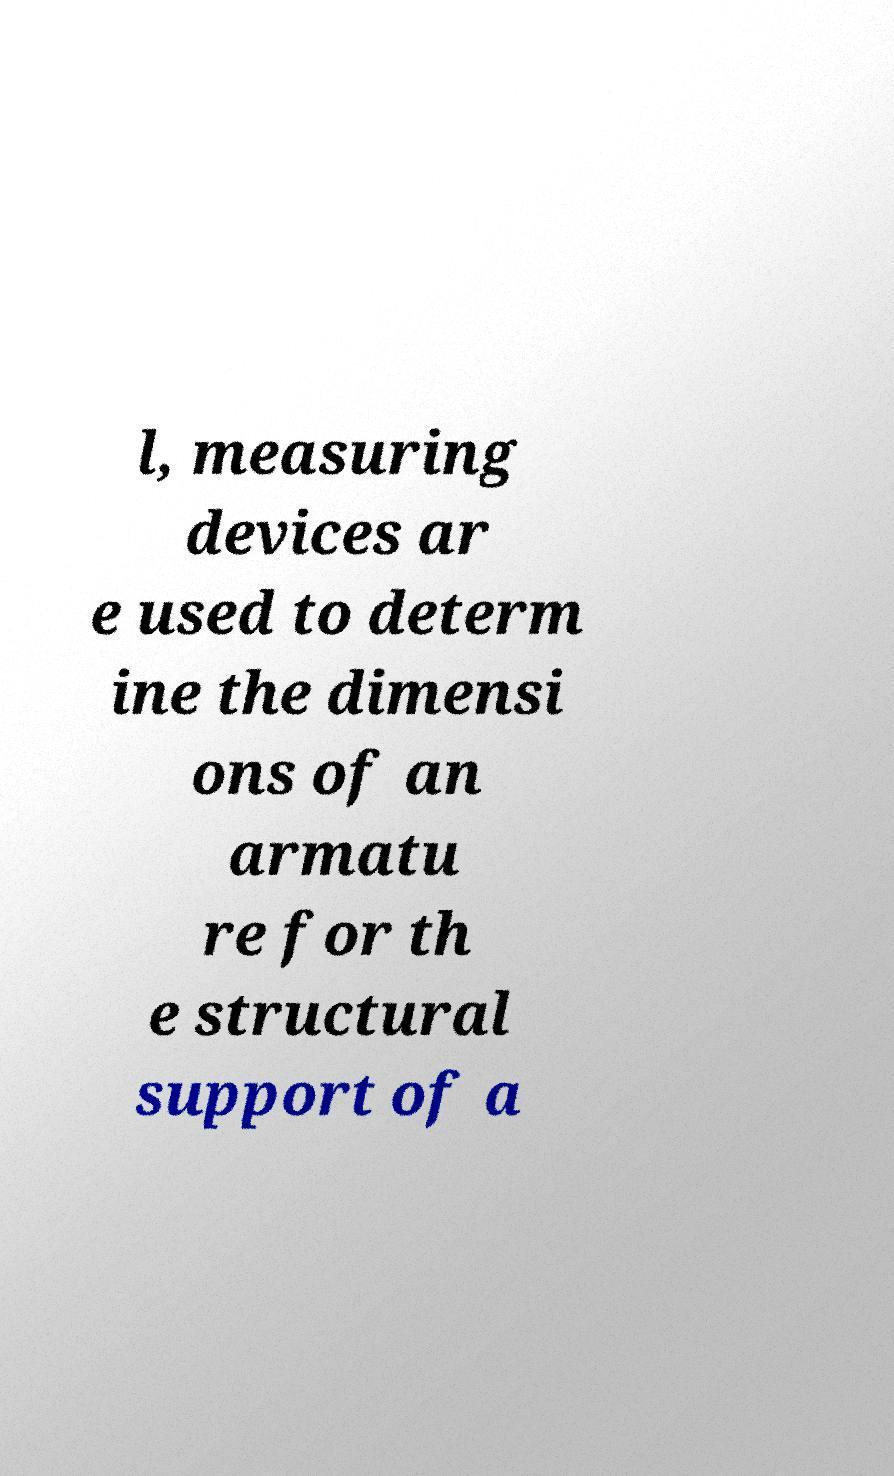Could you extract and type out the text from this image? l, measuring devices ar e used to determ ine the dimensi ons of an armatu re for th e structural support of a 